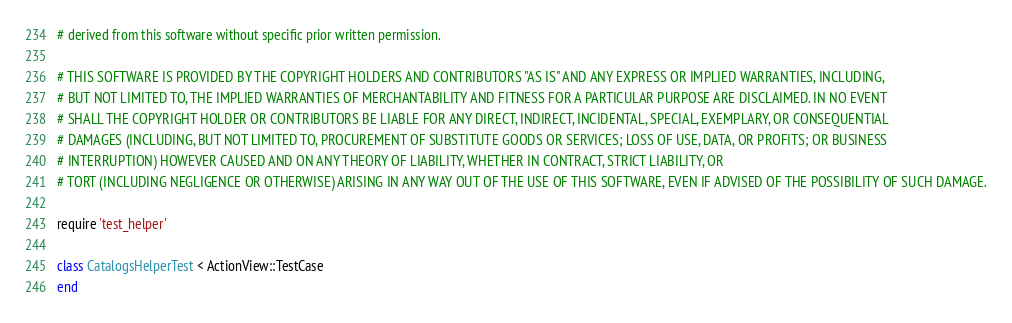Convert code to text. <code><loc_0><loc_0><loc_500><loc_500><_Ruby_># derived from this software without specific prior written permission.

# THIS SOFTWARE IS PROVIDED BY THE COPYRIGHT HOLDERS AND CONTRIBUTORS "AS IS" AND ANY EXPRESS OR IMPLIED WARRANTIES, INCLUDING,
# BUT NOT LIMITED TO, THE IMPLIED WARRANTIES OF MERCHANTABILITY AND FITNESS FOR A PARTICULAR PURPOSE ARE DISCLAIMED. IN NO EVENT
# SHALL THE COPYRIGHT HOLDER OR CONTRIBUTORS BE LIABLE FOR ANY DIRECT, INDIRECT, INCIDENTAL, SPECIAL, EXEMPLARY, OR CONSEQUENTIAL
# DAMAGES (INCLUDING, BUT NOT LIMITED TO, PROCUREMENT OF SUBSTITUTE GOODS OR SERVICES; LOSS OF USE, DATA, OR PROFITS; OR BUSINESS
# INTERRUPTION) HOWEVER CAUSED AND ON ANY THEORY OF LIABILITY, WHETHER IN CONTRACT, STRICT LIABILITY, OR
# TORT (INCLUDING NEGLIGENCE OR OTHERWISE) ARISING IN ANY WAY OUT OF THE USE OF THIS SOFTWARE, EVEN IF ADVISED OF THE POSSIBILITY OF SUCH DAMAGE.

require 'test_helper'

class CatalogsHelperTest < ActionView::TestCase
end
</code> 